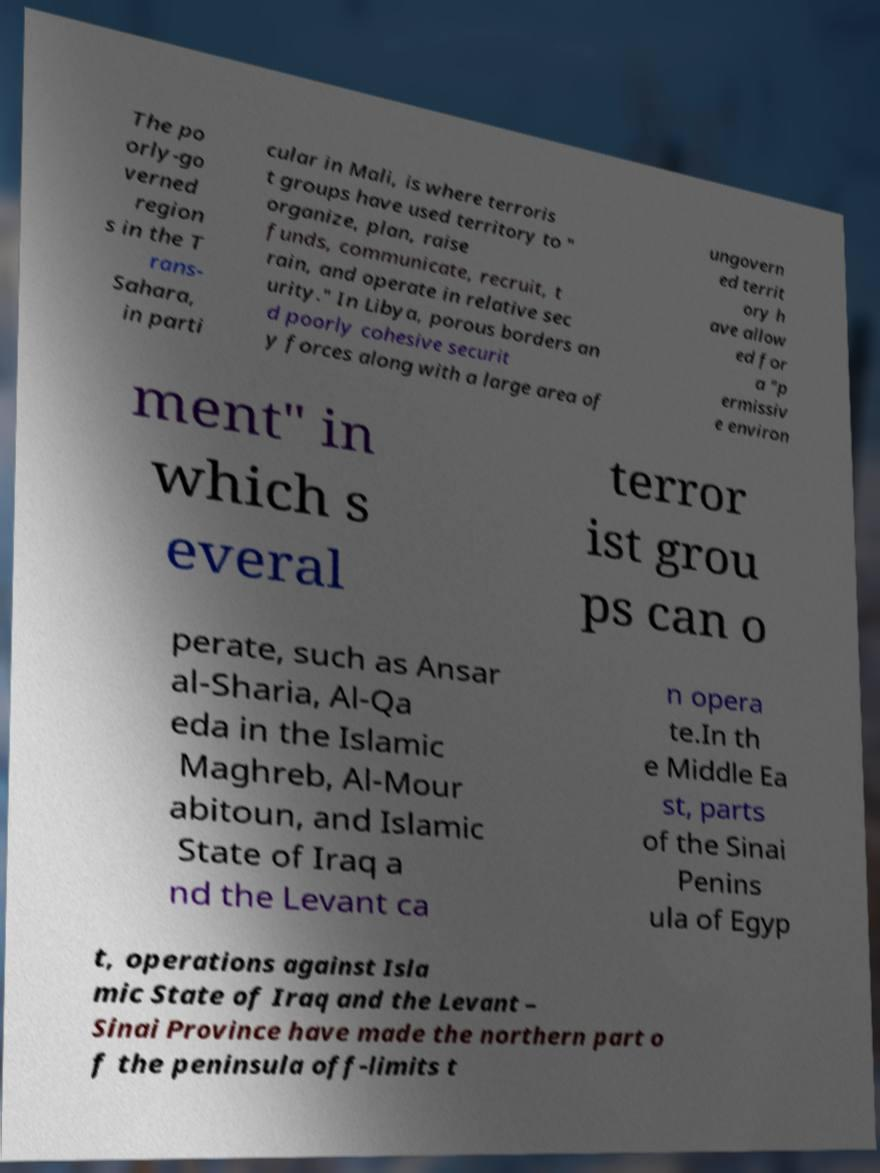Could you extract and type out the text from this image? The po orly-go verned region s in the T rans- Sahara, in parti cular in Mali, is where terroris t groups have used territory to " organize, plan, raise funds, communicate, recruit, t rain, and operate in relative sec urity." In Libya, porous borders an d poorly cohesive securit y forces along with a large area of ungovern ed territ ory h ave allow ed for a "p ermissiv e environ ment" in which s everal terror ist grou ps can o perate, such as Ansar al-Sharia, Al-Qa eda in the Islamic Maghreb, Al-Mour abitoun, and Islamic State of Iraq a nd the Levant ca n opera te.In th e Middle Ea st, parts of the Sinai Penins ula of Egyp t, operations against Isla mic State of Iraq and the Levant – Sinai Province have made the northern part o f the peninsula off-limits t 